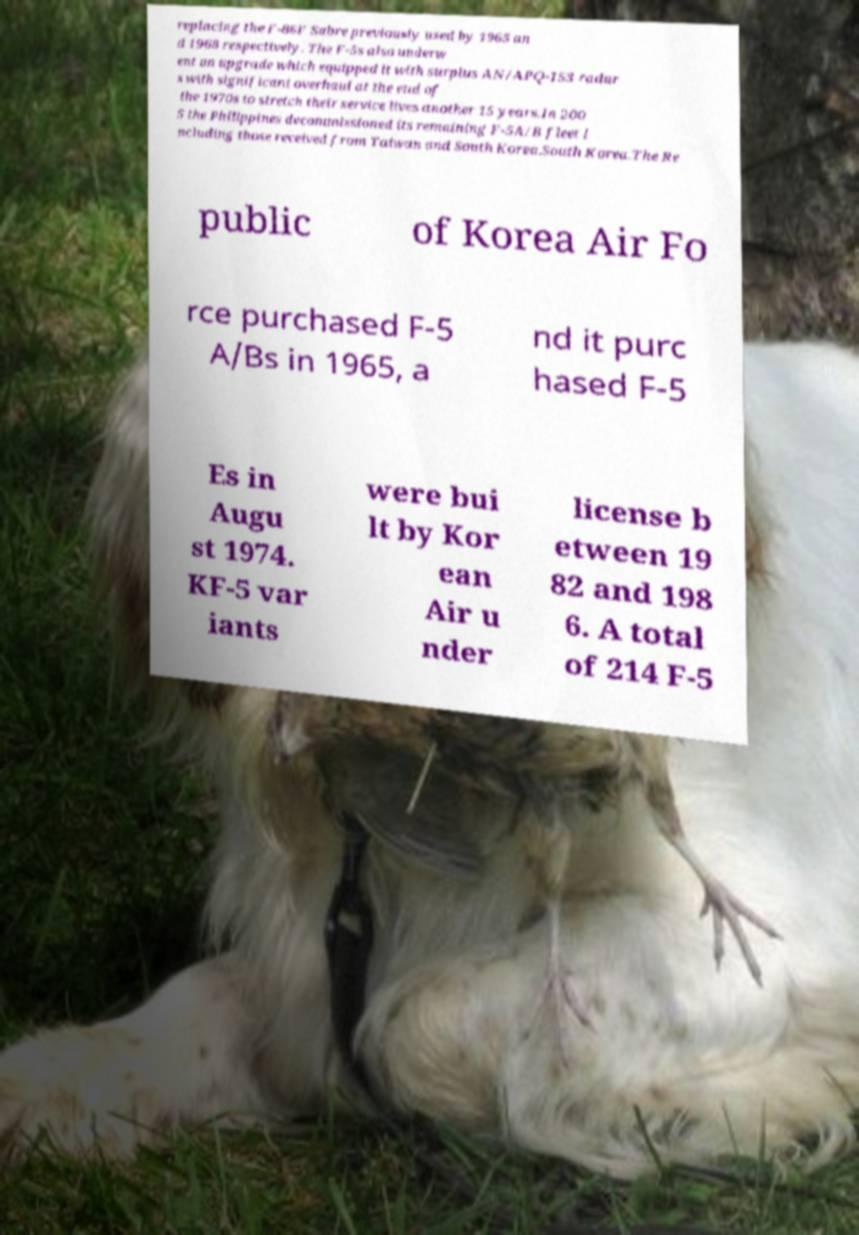For documentation purposes, I need the text within this image transcribed. Could you provide that? replacing the F-86F Sabre previously used by 1965 an d 1968 respectively. The F-5s also underw ent an upgrade which equipped it with surplus AN/APQ-153 radar s with significant overhaul at the end of the 1970s to stretch their service lives another 15 years.In 200 5 the Philippines decommissioned its remaining F-5A/B fleet i ncluding those received from Taiwan and South Korea.South Korea.The Re public of Korea Air Fo rce purchased F-5 A/Bs in 1965, a nd it purc hased F-5 Es in Augu st 1974. KF-5 var iants were bui lt by Kor ean Air u nder license b etween 19 82 and 198 6. A total of 214 F-5 